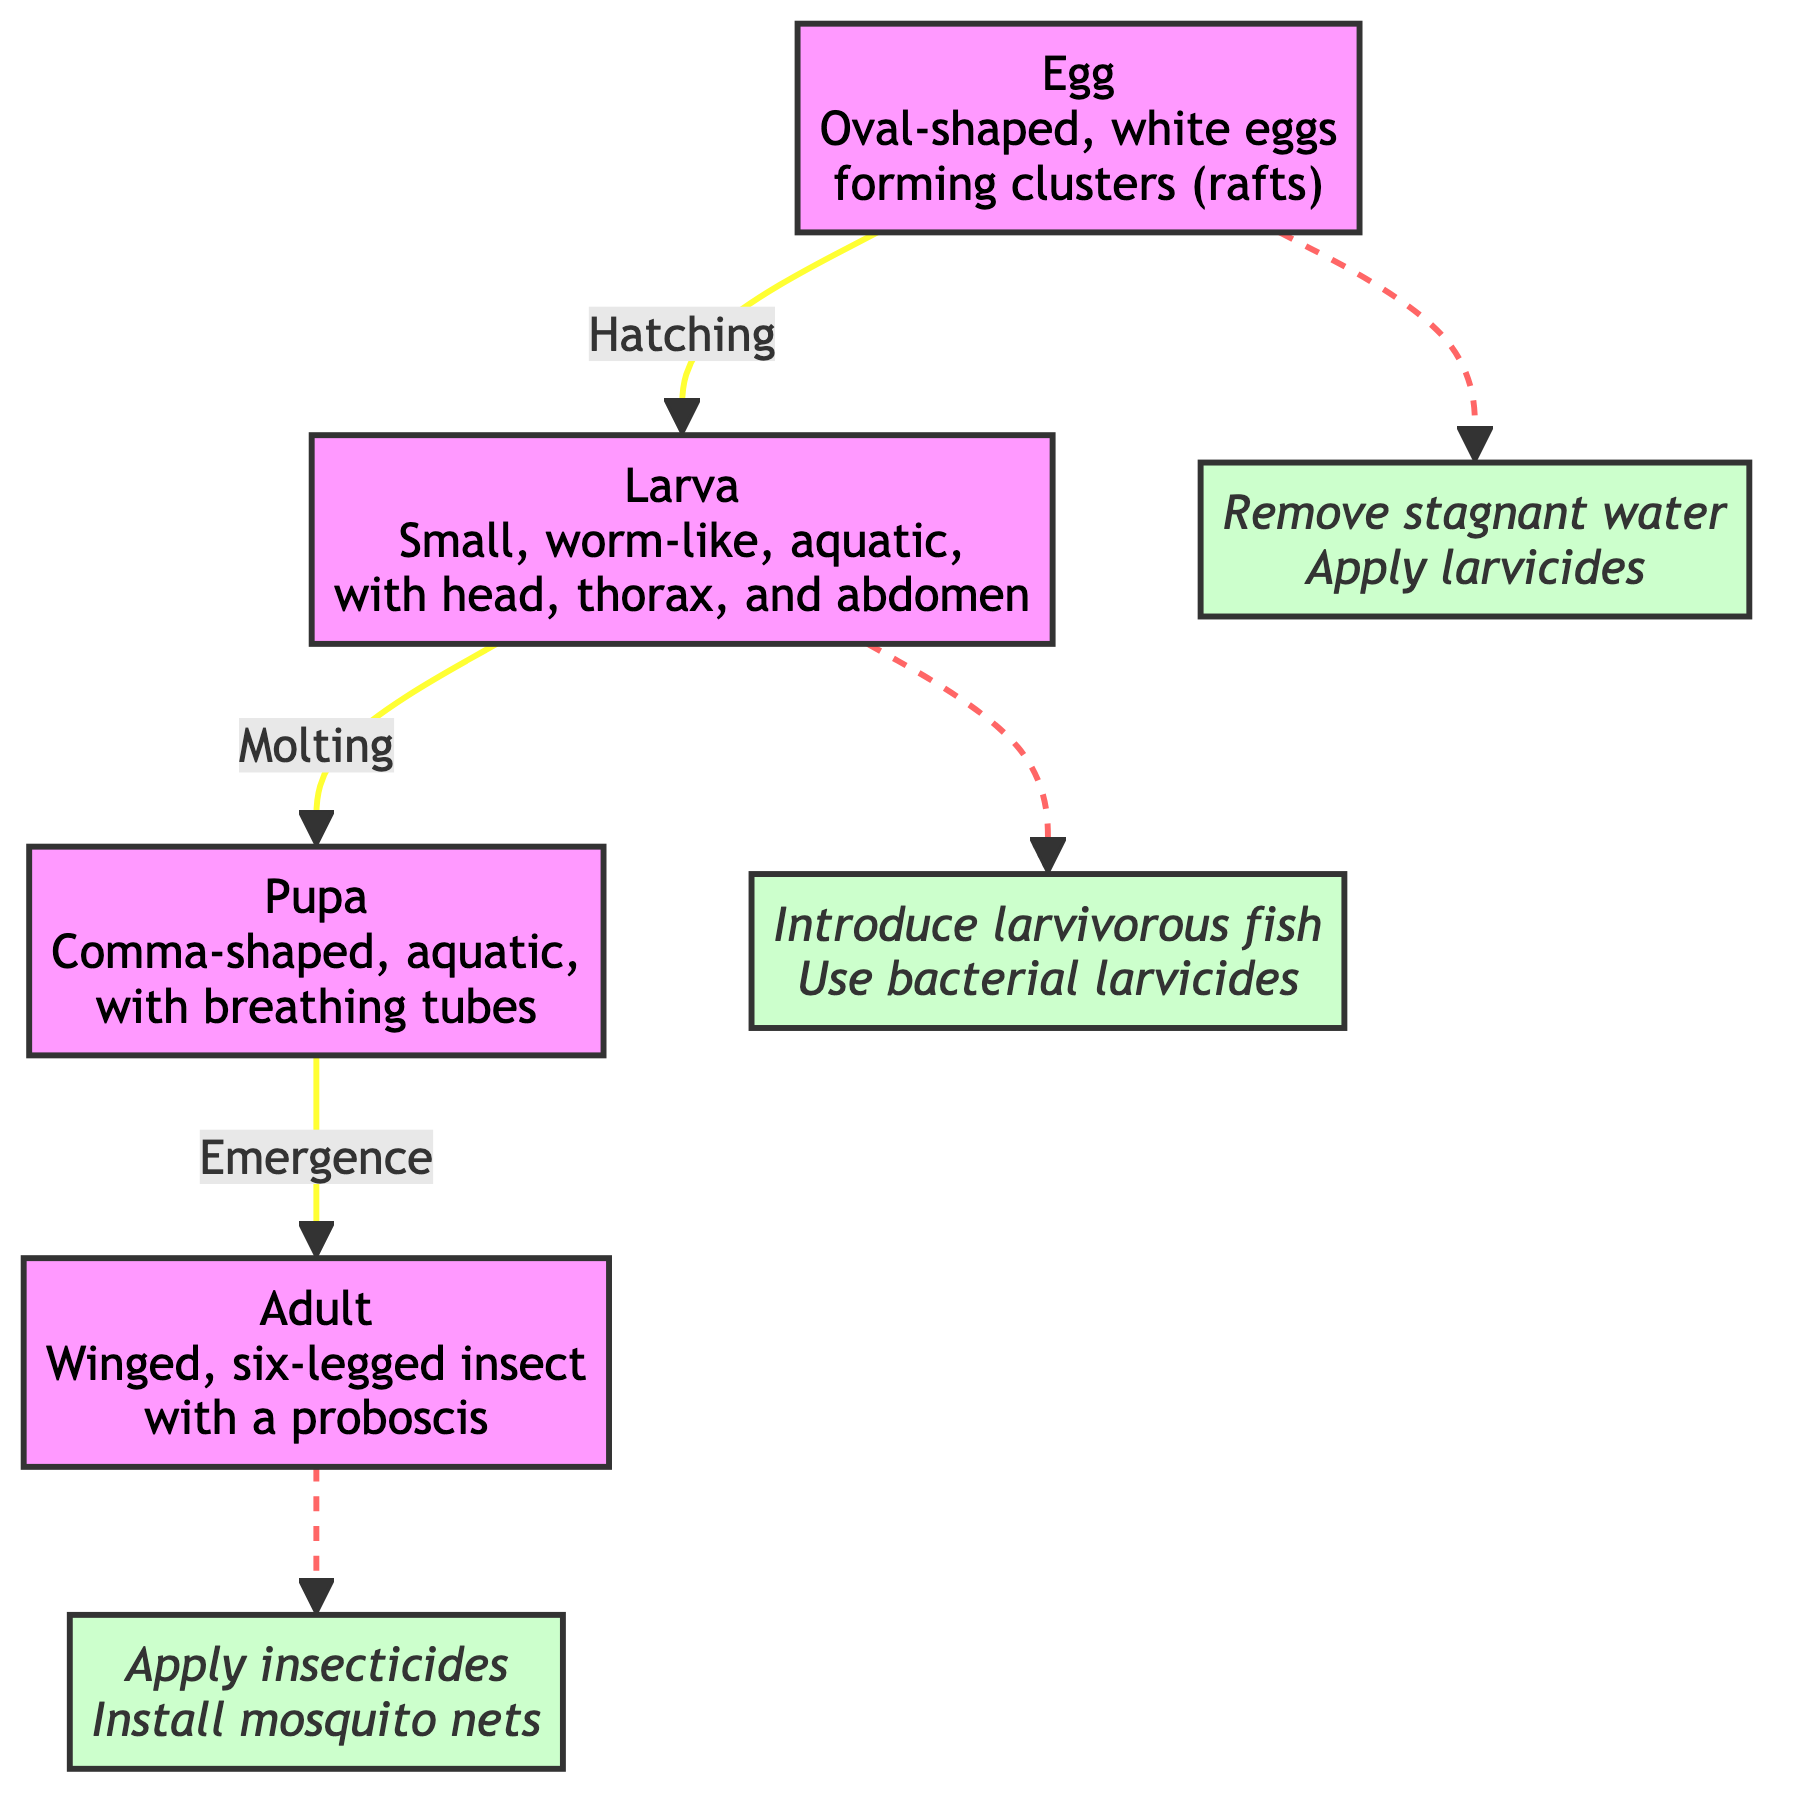What is the first stage of the mosquito's life cycle? The first stage, as indicated in the diagram, is the "Egg." It is described as oval-shaped, white eggs forming clusters (rafts).
Answer: Egg How does the larva stage transform into the pupa stage? The transition from the larva stage to the pupa stage is indicated by the process of "Molting." This process involves shedding the larval skin, which leads to the transformation into the pupa.
Answer: Molting How many intervention points are highlighted in the diagram? The diagram has three intervention points that are indicated by dashed lines from the various stages, specifically targeting stages at the egg, larva, and adult stages.
Answer: 3 What is the shape of the pupa in the mosquito life cycle? The pupa is described in the diagram as comma-shaped, which highlights its distinctive form compared to other stages.
Answer: Comma-shaped What is the recommended intervention for the adult stage of the mosquito? The intervention point for the adult stage involves applying insecticides and installing mosquito nets, as indicated in the diagram.
Answer: Apply insecticides What products can be used during the larval stage? For the larval stage, the diagram suggests introducing larvivorous fish and using bacterial larvicides to control the population of mosquitoes.
Answer: Introduce larvivorous fish In the context of the life cycle, which stage does not involve water? The adult stage of the mosquito is the only stage that is not aquatic and can live outside of water, unlike the egg, larva, and pupa stages.
Answer: Adult What does the egg stage lead to? The egg stage leads to the larva stage as indicated by the directional flow labeled "Hatching," which describes the transition from egg to larva.
Answer: Larva 